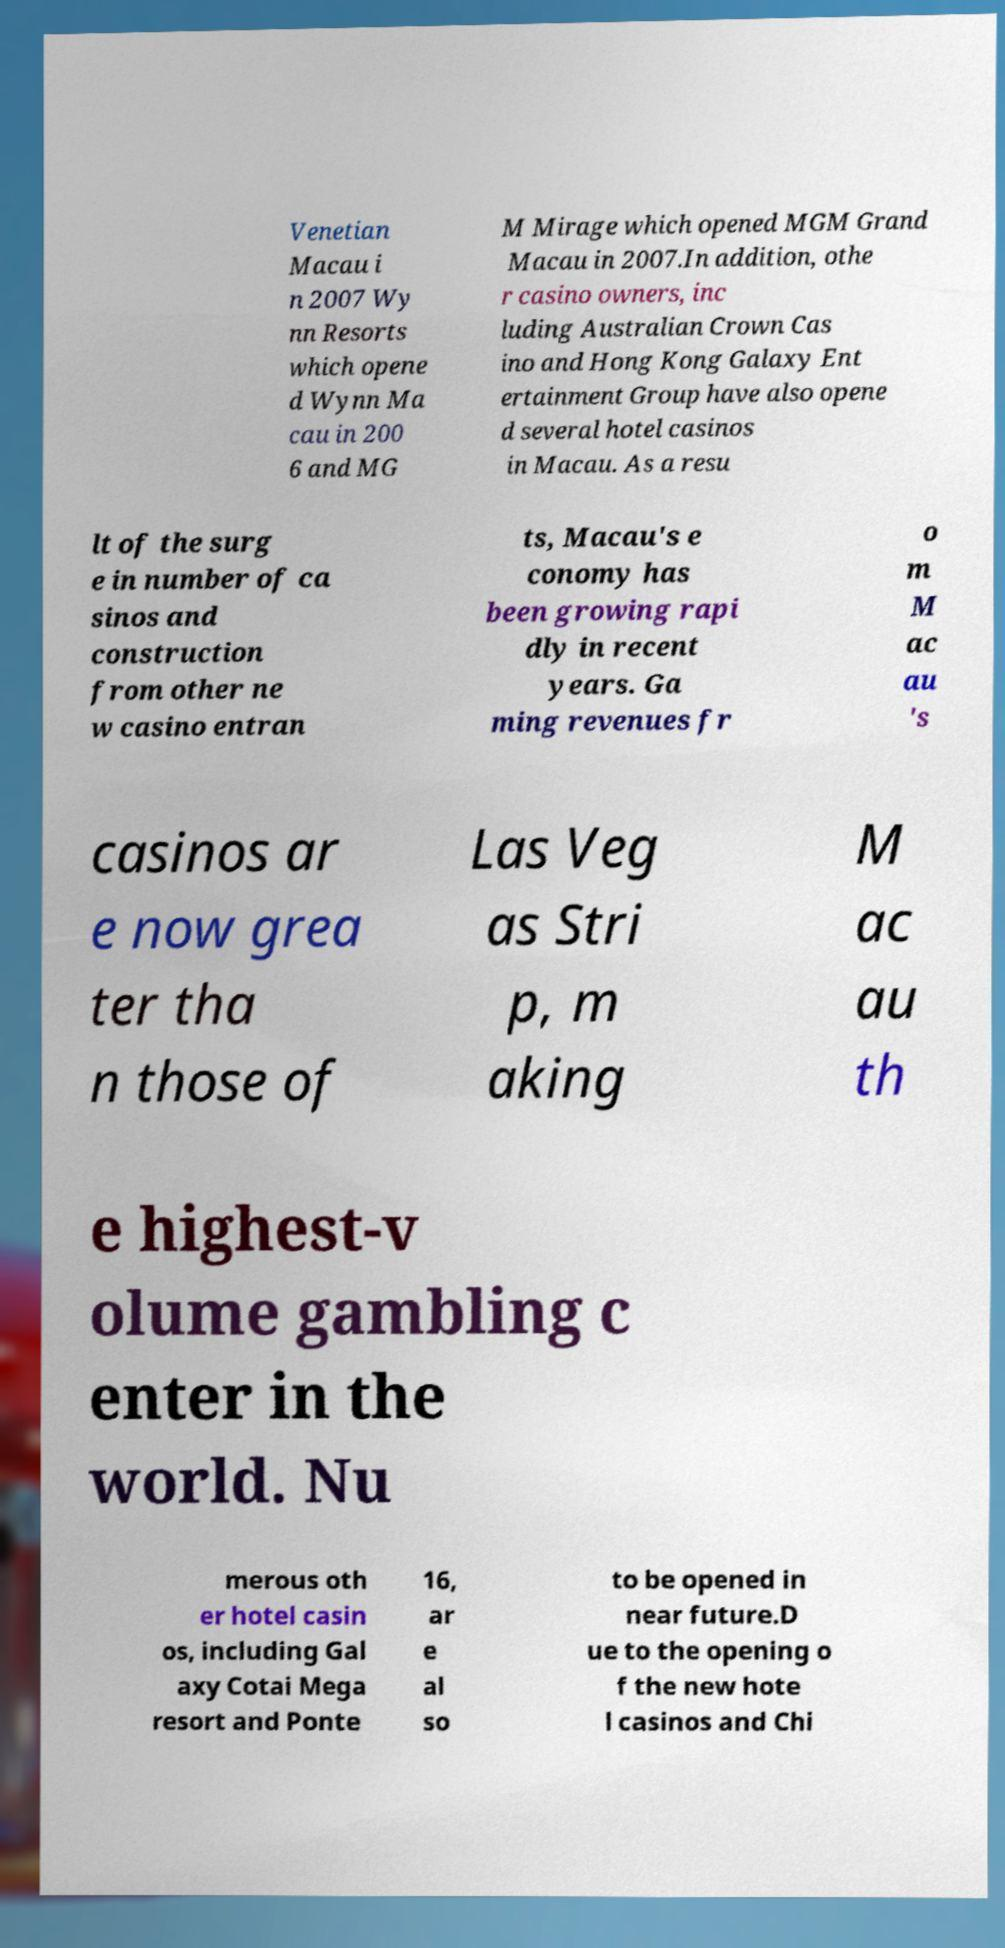Could you extract and type out the text from this image? Venetian Macau i n 2007 Wy nn Resorts which opene d Wynn Ma cau in 200 6 and MG M Mirage which opened MGM Grand Macau in 2007.In addition, othe r casino owners, inc luding Australian Crown Cas ino and Hong Kong Galaxy Ent ertainment Group have also opene d several hotel casinos in Macau. As a resu lt of the surg e in number of ca sinos and construction from other ne w casino entran ts, Macau's e conomy has been growing rapi dly in recent years. Ga ming revenues fr o m M ac au 's casinos ar e now grea ter tha n those of Las Veg as Stri p, m aking M ac au th e highest-v olume gambling c enter in the world. Nu merous oth er hotel casin os, including Gal axy Cotai Mega resort and Ponte 16, ar e al so to be opened in near future.D ue to the opening o f the new hote l casinos and Chi 